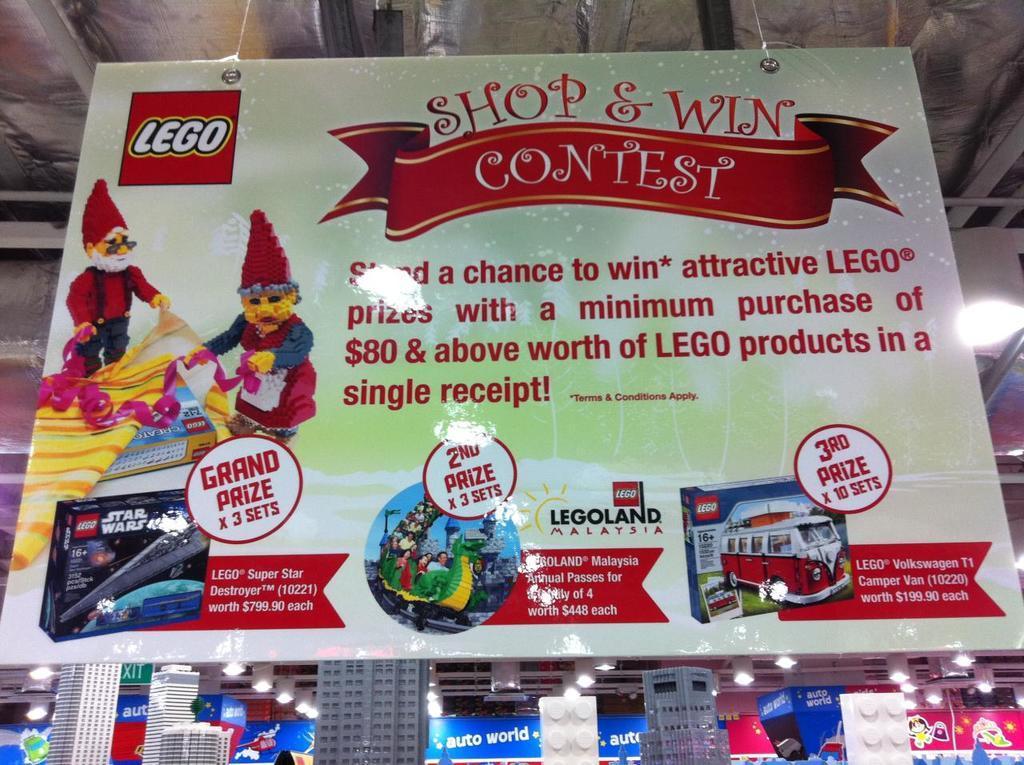In one or two sentences, can you explain what this image depicts? In this picture in the front there is a banner with some text written on it. In the background there are building models, lights and there are boards with some text written on it. 